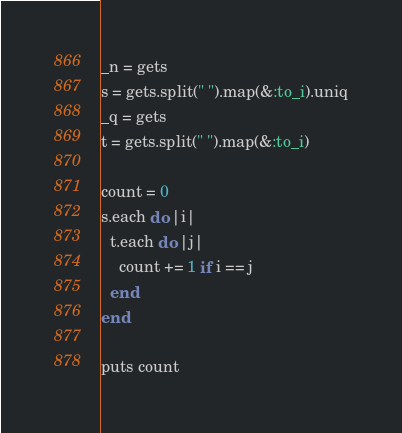Convert code to text. <code><loc_0><loc_0><loc_500><loc_500><_Ruby_>_n = gets
s = gets.split(" ").map(&:to_i).uniq
_q = gets
t = gets.split(" ").map(&:to_i)

count = 0
s.each do |i|
  t.each do |j|
    count += 1 if i == j 
  end
end

puts count
</code> 